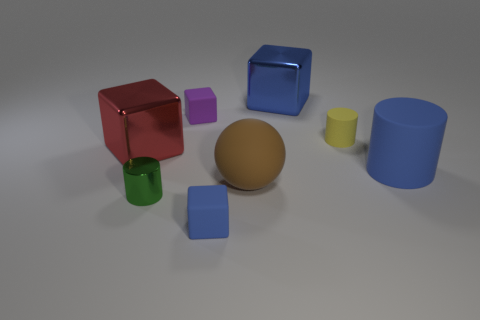Is there a thing that has the same color as the large matte cylinder?
Your response must be concise. Yes. Is there a yellow metallic sphere?
Ensure brevity in your answer.  No. There is a cylinder to the right of the yellow rubber thing; is it the same size as the purple rubber thing?
Offer a very short reply. No. Are there fewer brown matte blocks than small yellow cylinders?
Your answer should be compact. Yes. There is a metal object that is on the right side of the tiny block to the left of the cube in front of the metallic cylinder; what shape is it?
Give a very brief answer. Cube. Are there any blue cubes that have the same material as the green cylinder?
Provide a succinct answer. Yes. There is a big rubber object on the right side of the blue shiny block; is it the same color as the tiny cube that is to the right of the purple cube?
Give a very brief answer. Yes. Is the number of big red metallic blocks in front of the tiny green metal cylinder less than the number of small green cylinders?
Your answer should be compact. Yes. What number of objects are red objects or big cubes on the right side of the small green cylinder?
Your response must be concise. 2. The big cylinder that is the same material as the purple thing is what color?
Offer a very short reply. Blue. 